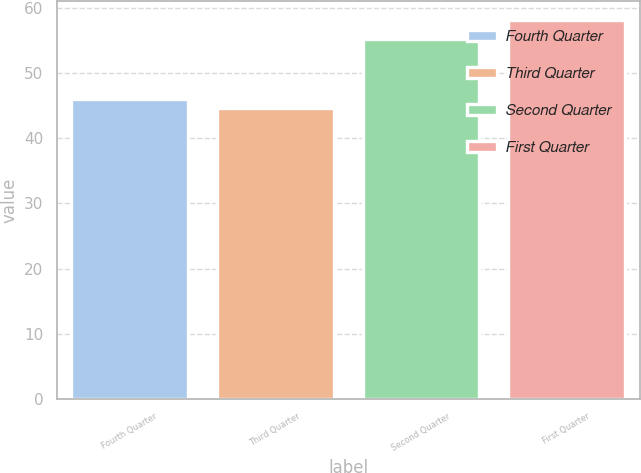Convert chart. <chart><loc_0><loc_0><loc_500><loc_500><bar_chart><fcel>Fourth Quarter<fcel>Third Quarter<fcel>Second Quarter<fcel>First Quarter<nl><fcel>46.05<fcel>44.7<fcel>55.25<fcel>58.19<nl></chart> 